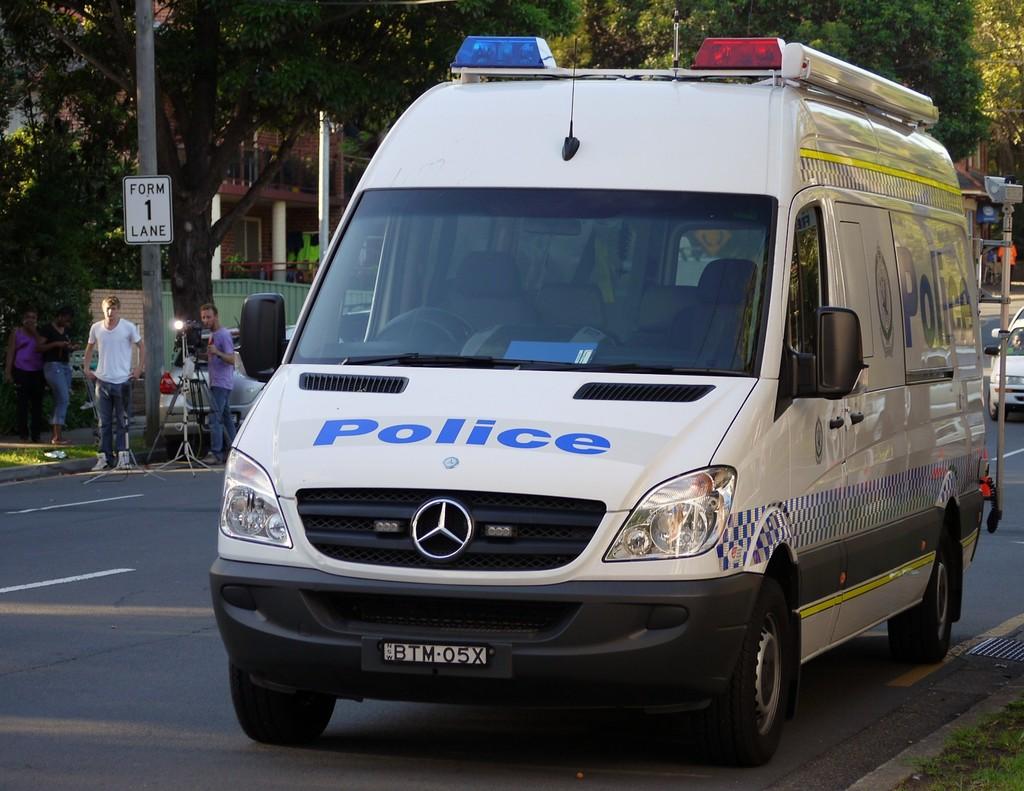What department does this van belong to?
Ensure brevity in your answer.  Police. How many lanes should be formed?
Keep it short and to the point. 1. 